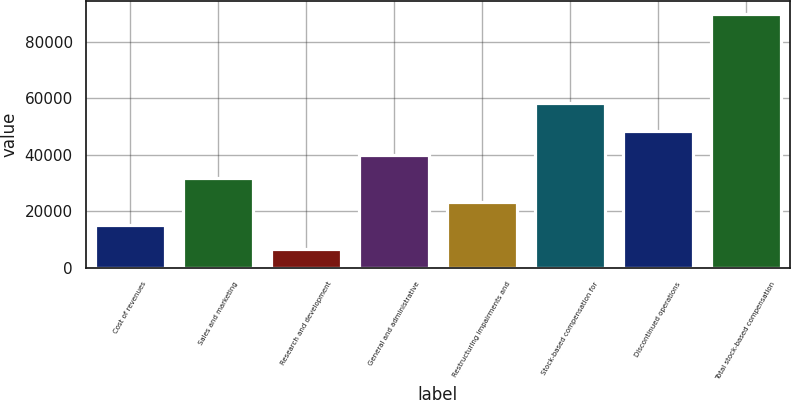Convert chart. <chart><loc_0><loc_0><loc_500><loc_500><bar_chart><fcel>Cost of revenues<fcel>Sales and marketing<fcel>Research and development<fcel>General and administrative<fcel>Restructuring impairments and<fcel>Stock-based compensation for<fcel>Discontinued operations<fcel>Total stock-based compensation<nl><fcel>15054.6<fcel>31723.8<fcel>6720<fcel>40058.4<fcel>23389.2<fcel>58479<fcel>48393<fcel>90066<nl></chart> 